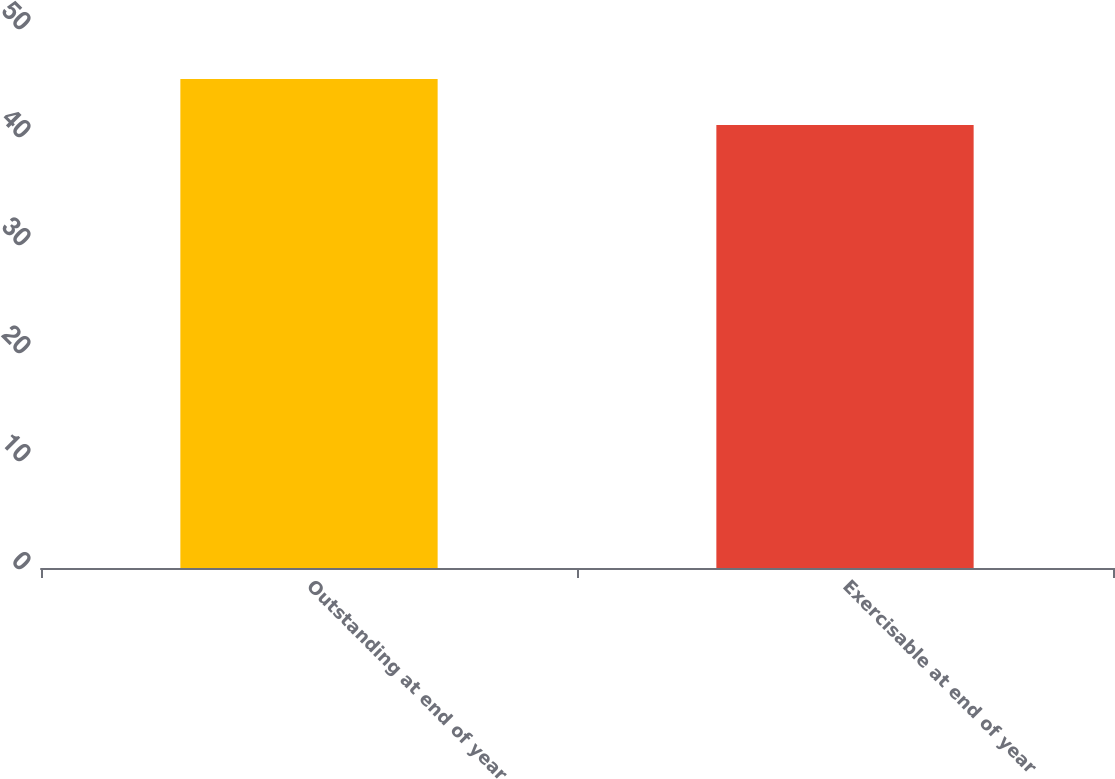Convert chart. <chart><loc_0><loc_0><loc_500><loc_500><bar_chart><fcel>Outstanding at end of year<fcel>Exercisable at end of year<nl><fcel>45.27<fcel>41.01<nl></chart> 